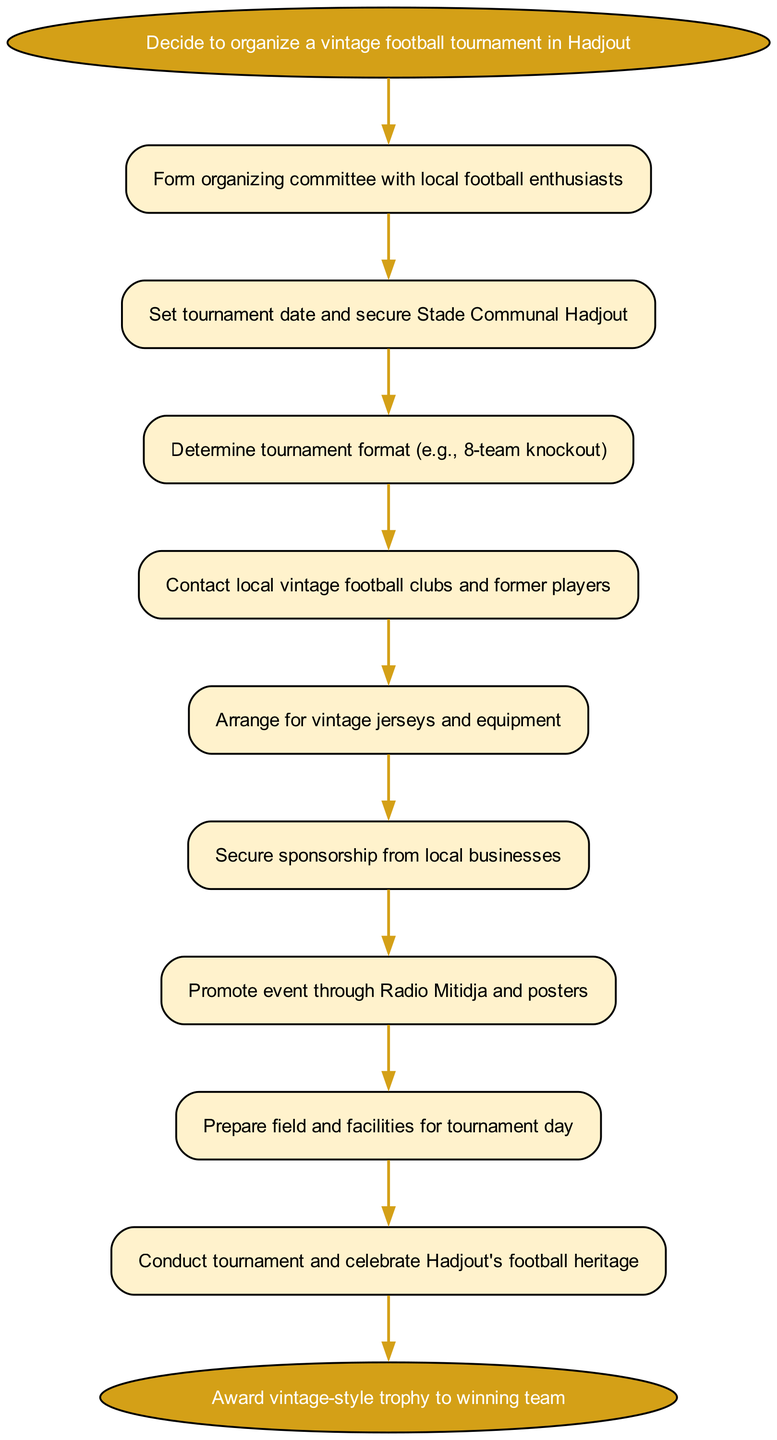What is the first step to organize the tournament? The first step is indicated by the start node of the diagram, which states, "Decide to organize a vintage football tournament in Hadjout."
Answer: Decide to organize a vintage football tournament in Hadjout How many steps are there in the tournament organization process? By counting the steps listed in the diagram, there are 8 direct steps mentioned along with the start and end nodes.
Answer: 8 What is the last action before awarding the trophy? The last action preceding the end node is "Conduct tournament and celebrate Hadjout's football heritage," which is the final step of the process.
Answer: Conduct tournament and celebrate Hadjout's football heritage Which node comes after contacting local vintage football clubs? The node that follows "Contact local vintage football clubs and former players" is "Arrange for vintage jerseys and equipment," indicating the next action in the flow.
Answer: Arrange for vintage jerseys and equipment What type of event is this flow chart describing? The overall theme of the diagram focuses on organizing a local football tournament specifically characterized as a "vintage" event.
Answer: Vintage football tournament What node connects the step of securing sponsorship? The "Secure sponsorship from local businesses" node connects directly to "Promote event through Radio Mitidja and posters," indicating a sequence of actions in the organization process.
Answer: Promote event through Radio Mitidja and posters What location is mentioned for securing the tournament? The location is specified in the step stating, "Set tournament date and secure Stade Communal Hadjout," clearly identifying the venue for the event.
Answer: Stade Communal Hadjout From which step does the tournament process begin? The process begins from the start node, specifically outlined as "Decide to organize a vintage football tournament in Hadjout," signifying the initiation of the plan.
Answer: Decide to organize a vintage football tournament in Hadjout 